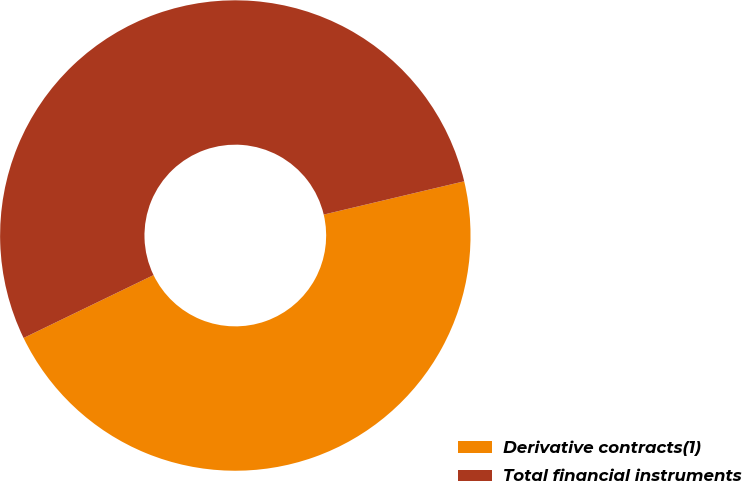<chart> <loc_0><loc_0><loc_500><loc_500><pie_chart><fcel>Derivative contracts(1)<fcel>Total financial instruments<nl><fcel>46.53%<fcel>53.47%<nl></chart> 